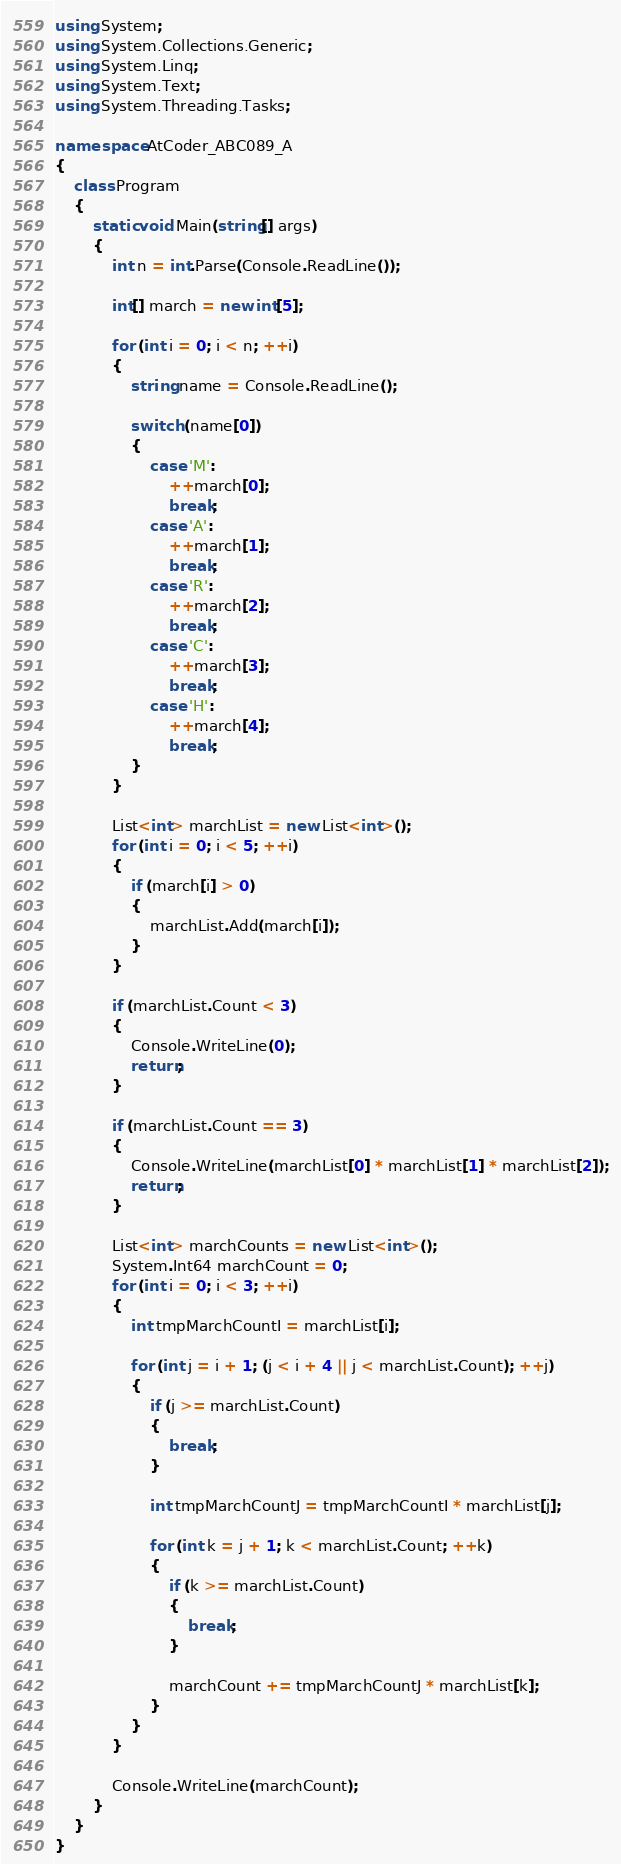Convert code to text. <code><loc_0><loc_0><loc_500><loc_500><_C#_>using System;
using System.Collections.Generic;
using System.Linq;
using System.Text;
using System.Threading.Tasks;

namespace AtCoder_ABC089_A
{
    class Program
    {
        static void Main(string[] args)
        {
            int n = int.Parse(Console.ReadLine());

            int[] march = new int[5];

            for (int i = 0; i < n; ++i)
            {
                string name = Console.ReadLine();

                switch (name[0])
                {
                    case 'M':
                        ++march[0];
                        break;
                    case 'A':
                        ++march[1];
                        break;
                    case 'R':
                        ++march[2];
                        break;
                    case 'C':
                        ++march[3];
                        break;
                    case 'H':
                        ++march[4];
                        break;
                }
            }

            List<int> marchList = new List<int>();
            for (int i = 0; i < 5; ++i)
            {
                if (march[i] > 0)
                {
                    marchList.Add(march[i]);
                }
            }

            if (marchList.Count < 3)
            {
                Console.WriteLine(0);
                return;
            }

            if (marchList.Count == 3)
            {
                Console.WriteLine(marchList[0] * marchList[1] * marchList[2]);
                return;
            }

            List<int> marchCounts = new List<int>();
            System.Int64 marchCount = 0;
            for (int i = 0; i < 3; ++i)
            {
                int tmpMarchCountI = marchList[i];

                for (int j = i + 1; (j < i + 4 || j < marchList.Count); ++j)
                {
                    if (j >= marchList.Count)
                    {
                        break;
                    }

                    int tmpMarchCountJ = tmpMarchCountI * marchList[j];

                    for (int k = j + 1; k < marchList.Count; ++k)
                    {
                        if (k >= marchList.Count)
                        {
                            break;
                        }

                        marchCount += tmpMarchCountJ * marchList[k];
                    }
                }
            }

            Console.WriteLine(marchCount);
        }
    }
}
</code> 